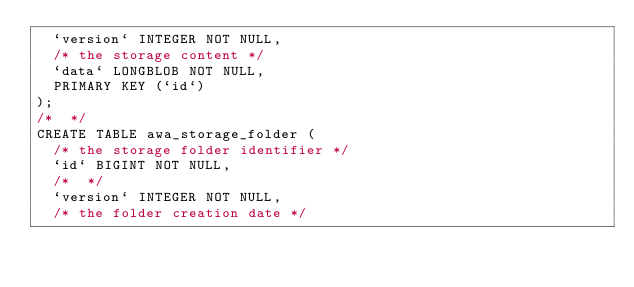<code> <loc_0><loc_0><loc_500><loc_500><_SQL_>  `version` INTEGER NOT NULL,
  /* the storage content */
  `data` LONGBLOB NOT NULL,
  PRIMARY KEY (`id`)
);
/*  */
CREATE TABLE awa_storage_folder (
  /* the storage folder identifier */
  `id` BIGINT NOT NULL,
  /*  */
  `version` INTEGER NOT NULL,
  /* the folder creation date */</code> 